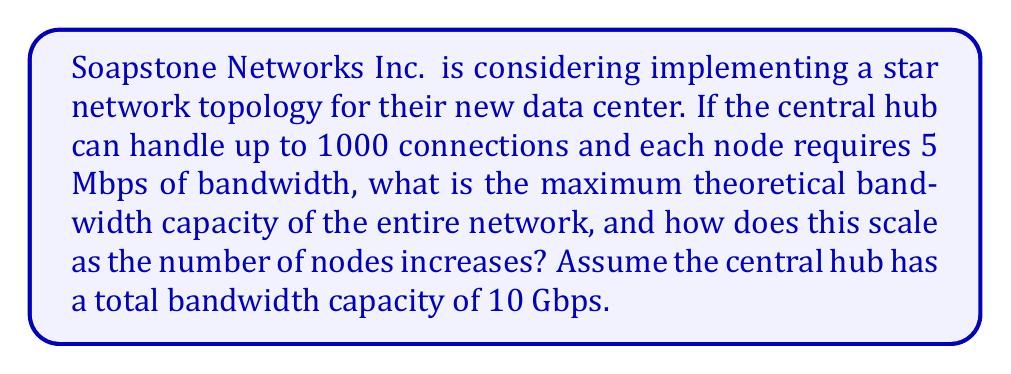Show me your answer to this math problem. To solve this problem, we need to consider the characteristics of a star network topology and the given constraints:

1. Maximum connections: 1000
2. Bandwidth per node: 5 Mbps
3. Total hub bandwidth: 10 Gbps

Let's approach this step-by-step:

1. Calculate the maximum theoretical bandwidth usage:
   $$ \text{Max Bandwidth} = \text{Number of connections} \times \text{Bandwidth per node} $$
   $$ = 1000 \times 5 \text{ Mbps} = 5000 \text{ Mbps} = 5 \text{ Gbps} $$

2. Compare with the hub's total bandwidth capacity:
   The hub can handle 10 Gbps, which is greater than the 5 Gbps required for all 1000 nodes.

3. Determine the scaling factor:
   Let $n$ be the number of nodes. The total bandwidth usage scales linearly with $n$:
   $$ B(n) = 5n \text{ Mbps} $$

4. Find the maximum number of nodes before reaching the hub's capacity:
   $$ 10 \text{ Gbps} = 10,000 \text{ Mbps} = 5n \text{ Mbps} $$
   $$ n = 2000 \text{ nodes} $$

5. Scalability analysis:
   The network scales linearly until it reaches the hub's bandwidth capacity or connection limit, whichever comes first. In this case, the bandwidth capacity is the limiting factor.

   The scalability can be expressed as a piecewise function:
   $$ B(n) = \begin{cases}
      5n \text{ Mbps}, & \text{if } n \leq 2000 \\
      10,000 \text{ Mbps}, & \text{if } 2000 < n \leq 1000
   \end{cases} $$

   This shows that the network's performance plateaus after reaching 2000 nodes, even though the hub can physically connect up to 1000 nodes.
Answer: The maximum theoretical bandwidth capacity of the entire network is 10 Gbps. The network scales linearly with the number of nodes up to 2000 nodes, following the function $B(n) = 5n \text{ Mbps}$ for $n \leq 2000$. After 2000 nodes, the bandwidth capacity remains constant at 10 Gbps due to the hub's limitations, even though it can physically connect up to 1000 nodes. 